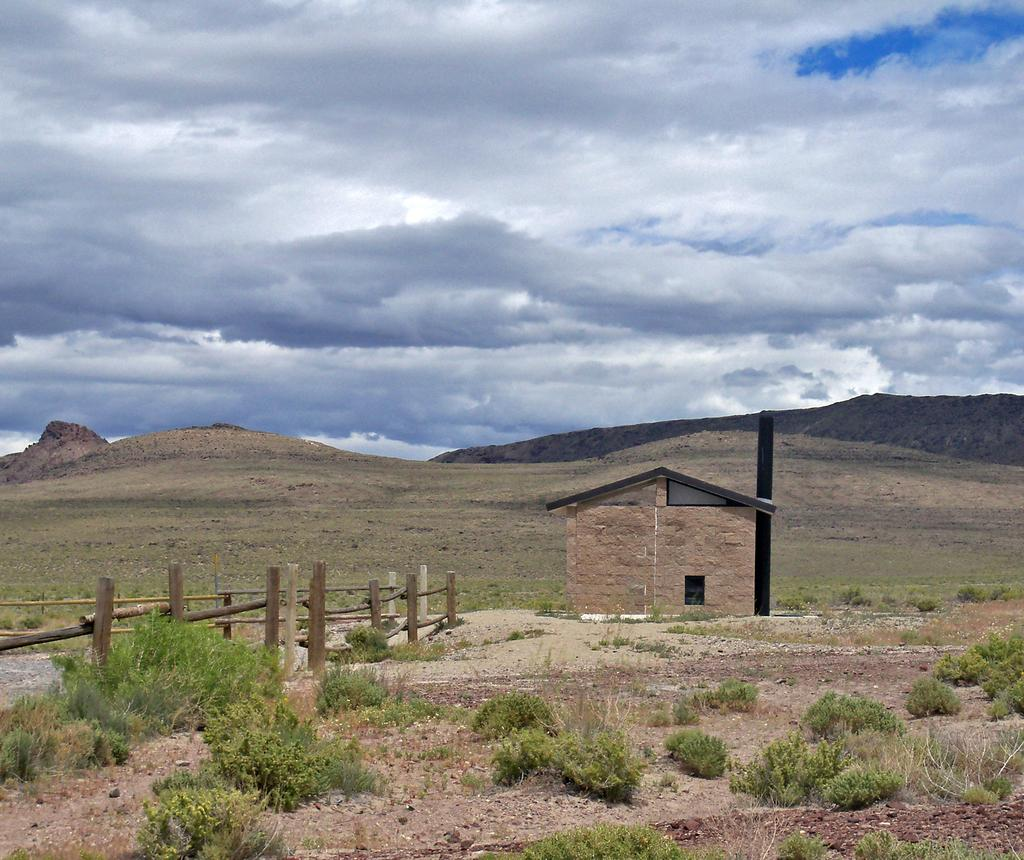What type of vegetation is at the bottom of the image? There are plants at the bottom of the image. What type of material is used for the fencing in the image? There is wooden fencing in the image. What type of structure is present in the image? There is a house in the image. What can be seen in the distance in the background of the image? Mountains and the sky are visible in the background of the image. What is the weather like in the image? The presence of clouds in the background suggests that it might be partly cloudy. How many sisters are visible in the image? There are no sisters present in the image. What type of crime is being committed in the image? There is no crime being committed in the image. What is the stocking used for in the image? There is no stocking present in the image. 